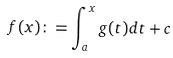<formula> <loc_0><loc_0><loc_500><loc_500>f ( x ) \colon = \int _ { a } ^ { x } g ( t ) d t + c</formula> 